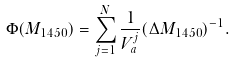Convert formula to latex. <formula><loc_0><loc_0><loc_500><loc_500>\Phi ( M _ { 1 4 5 0 } ) = \sum ^ { N } _ { j = 1 } \frac { 1 } { V _ { a } ^ { j } } ( \Delta M _ { 1 4 5 0 } ) ^ { - 1 } .</formula> 